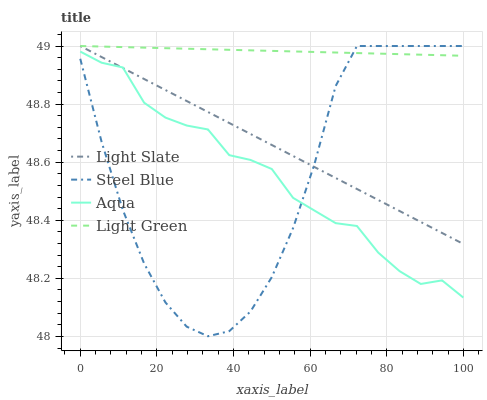Does Steel Blue have the minimum area under the curve?
Answer yes or no. Yes. Does Light Green have the maximum area under the curve?
Answer yes or no. Yes. Does Aqua have the minimum area under the curve?
Answer yes or no. No. Does Aqua have the maximum area under the curve?
Answer yes or no. No. Is Light Slate the smoothest?
Answer yes or no. Yes. Is Steel Blue the roughest?
Answer yes or no. Yes. Is Aqua the smoothest?
Answer yes or no. No. Is Aqua the roughest?
Answer yes or no. No. Does Aqua have the lowest value?
Answer yes or no. No. Does Aqua have the highest value?
Answer yes or no. No. Is Aqua less than Light Green?
Answer yes or no. Yes. Is Light Green greater than Aqua?
Answer yes or no. Yes. Does Aqua intersect Light Green?
Answer yes or no. No. 